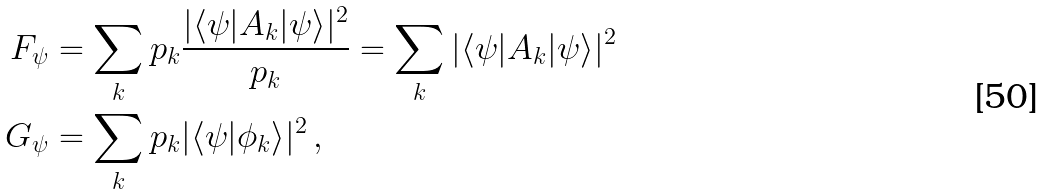Convert formula to latex. <formula><loc_0><loc_0><loc_500><loc_500>F _ { \psi } & = \sum _ { k } p _ { k } \frac { | \langle \psi | A _ { k } | \psi \rangle | ^ { 2 } } { p _ { k } } = \sum _ { k } | \langle \psi | A _ { k } | \psi \rangle | ^ { 2 } \\ G _ { \psi } & = \sum _ { k } p _ { k } | \langle \psi | \phi _ { k } \rangle | ^ { 2 } \, ,</formula> 